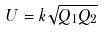Convert formula to latex. <formula><loc_0><loc_0><loc_500><loc_500>U = k \sqrt { Q _ { 1 } Q _ { 2 } }</formula> 